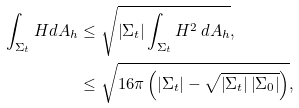<formula> <loc_0><loc_0><loc_500><loc_500>\int _ { \Sigma _ { t } } H d A _ { h } & \leq \sqrt { \left | \Sigma _ { t } \right | \int _ { \Sigma _ { t } } H ^ { 2 } \, d A _ { h } } , \\ & \leq \sqrt { 1 6 \pi \left ( \left | \Sigma _ { t } \right | - \sqrt { \left | \Sigma _ { t } \right | \left | \Sigma _ { 0 } \right | } \right ) } ,</formula> 